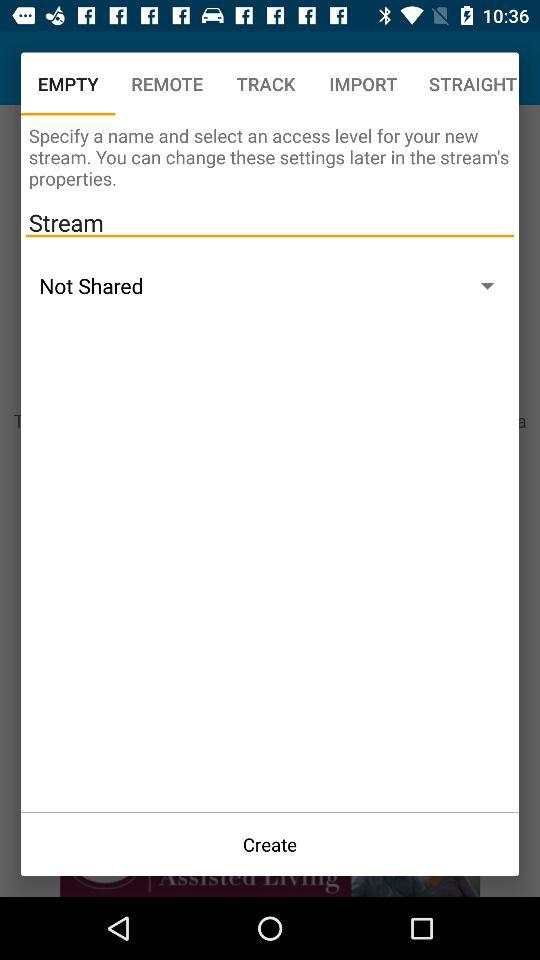Which tab is selected? The selected tab is "EMPTY". 